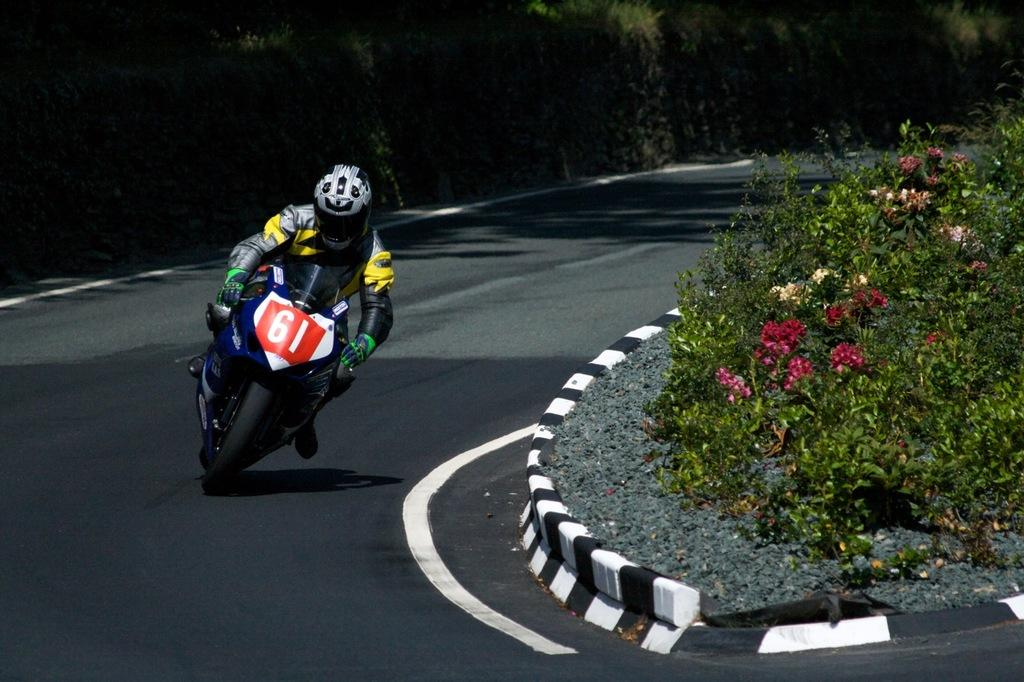Who is the person in the image? There is a man in the image. What is the man doing in the image? The man is driving a bike in the image. Where is the bike located in the image? The bike is on the road in the image. What can be seen on the right side of the image? There are flowers on plants on the right side of the image. What is visible in the background of the image? There are many trees in the background of the image. What type of cord is being used to water the trees in the image? There is no cord visible in the image, and no indication that the trees are being watered. 